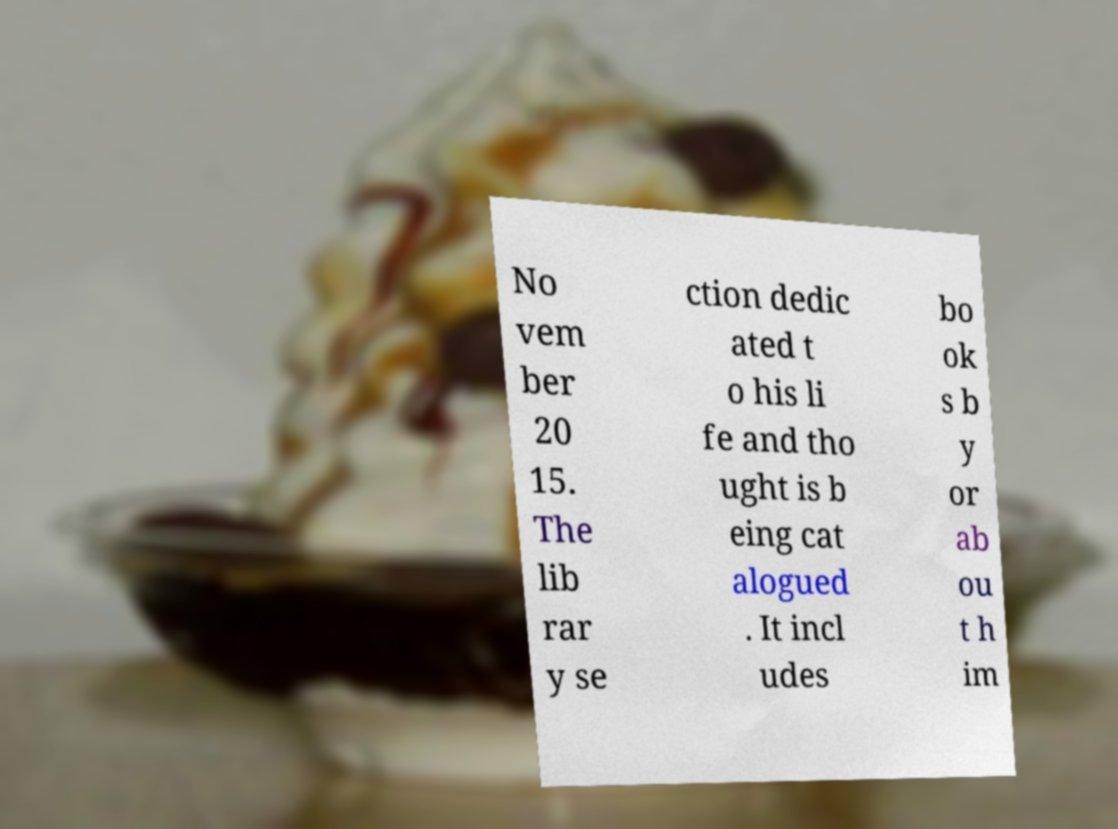Could you assist in decoding the text presented in this image and type it out clearly? No vem ber 20 15. The lib rar y se ction dedic ated t o his li fe and tho ught is b eing cat alogued . It incl udes bo ok s b y or ab ou t h im 